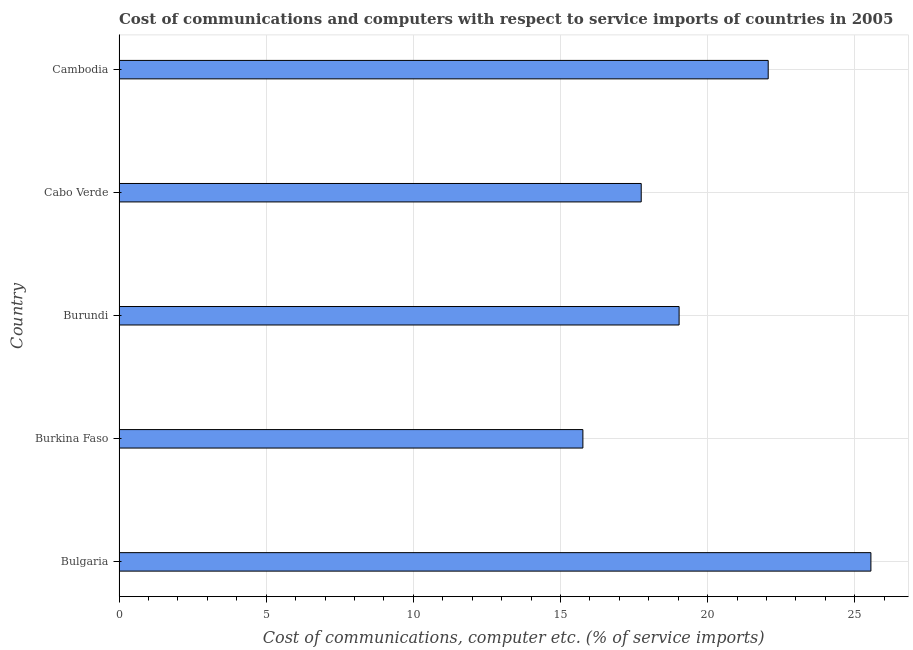Does the graph contain any zero values?
Provide a short and direct response. No. Does the graph contain grids?
Keep it short and to the point. Yes. What is the title of the graph?
Keep it short and to the point. Cost of communications and computers with respect to service imports of countries in 2005. What is the label or title of the X-axis?
Give a very brief answer. Cost of communications, computer etc. (% of service imports). What is the label or title of the Y-axis?
Make the answer very short. Country. What is the cost of communications and computer in Cabo Verde?
Your response must be concise. 17.74. Across all countries, what is the maximum cost of communications and computer?
Give a very brief answer. 25.55. Across all countries, what is the minimum cost of communications and computer?
Your answer should be compact. 15.76. In which country was the cost of communications and computer minimum?
Make the answer very short. Burkina Faso. What is the sum of the cost of communications and computer?
Keep it short and to the point. 100.13. What is the difference between the cost of communications and computer in Bulgaria and Burundi?
Make the answer very short. 6.52. What is the average cost of communications and computer per country?
Provide a short and direct response. 20.03. What is the median cost of communications and computer?
Provide a succinct answer. 19.03. In how many countries, is the cost of communications and computer greater than 15 %?
Your response must be concise. 5. What is the ratio of the cost of communications and computer in Bulgaria to that in Burkina Faso?
Give a very brief answer. 1.62. What is the difference between the highest and the second highest cost of communications and computer?
Offer a terse response. 3.49. Is the sum of the cost of communications and computer in Bulgaria and Cambodia greater than the maximum cost of communications and computer across all countries?
Offer a very short reply. Yes. What is the difference between the highest and the lowest cost of communications and computer?
Ensure brevity in your answer.  9.79. In how many countries, is the cost of communications and computer greater than the average cost of communications and computer taken over all countries?
Ensure brevity in your answer.  2. How many countries are there in the graph?
Provide a short and direct response. 5. What is the difference between two consecutive major ticks on the X-axis?
Make the answer very short. 5. Are the values on the major ticks of X-axis written in scientific E-notation?
Your response must be concise. No. What is the Cost of communications, computer etc. (% of service imports) in Bulgaria?
Provide a succinct answer. 25.55. What is the Cost of communications, computer etc. (% of service imports) of Burkina Faso?
Make the answer very short. 15.76. What is the Cost of communications, computer etc. (% of service imports) in Burundi?
Your answer should be compact. 19.03. What is the Cost of communications, computer etc. (% of service imports) of Cabo Verde?
Keep it short and to the point. 17.74. What is the Cost of communications, computer etc. (% of service imports) in Cambodia?
Keep it short and to the point. 22.06. What is the difference between the Cost of communications, computer etc. (% of service imports) in Bulgaria and Burkina Faso?
Ensure brevity in your answer.  9.79. What is the difference between the Cost of communications, computer etc. (% of service imports) in Bulgaria and Burundi?
Provide a short and direct response. 6.52. What is the difference between the Cost of communications, computer etc. (% of service imports) in Bulgaria and Cabo Verde?
Give a very brief answer. 7.8. What is the difference between the Cost of communications, computer etc. (% of service imports) in Bulgaria and Cambodia?
Your response must be concise. 3.49. What is the difference between the Cost of communications, computer etc. (% of service imports) in Burkina Faso and Burundi?
Your answer should be compact. -3.27. What is the difference between the Cost of communications, computer etc. (% of service imports) in Burkina Faso and Cabo Verde?
Provide a succinct answer. -1.98. What is the difference between the Cost of communications, computer etc. (% of service imports) in Burkina Faso and Cambodia?
Make the answer very short. -6.3. What is the difference between the Cost of communications, computer etc. (% of service imports) in Burundi and Cabo Verde?
Offer a terse response. 1.29. What is the difference between the Cost of communications, computer etc. (% of service imports) in Burundi and Cambodia?
Your answer should be compact. -3.03. What is the difference between the Cost of communications, computer etc. (% of service imports) in Cabo Verde and Cambodia?
Your answer should be very brief. -4.31. What is the ratio of the Cost of communications, computer etc. (% of service imports) in Bulgaria to that in Burkina Faso?
Make the answer very short. 1.62. What is the ratio of the Cost of communications, computer etc. (% of service imports) in Bulgaria to that in Burundi?
Your response must be concise. 1.34. What is the ratio of the Cost of communications, computer etc. (% of service imports) in Bulgaria to that in Cabo Verde?
Keep it short and to the point. 1.44. What is the ratio of the Cost of communications, computer etc. (% of service imports) in Bulgaria to that in Cambodia?
Give a very brief answer. 1.16. What is the ratio of the Cost of communications, computer etc. (% of service imports) in Burkina Faso to that in Burundi?
Ensure brevity in your answer.  0.83. What is the ratio of the Cost of communications, computer etc. (% of service imports) in Burkina Faso to that in Cabo Verde?
Provide a short and direct response. 0.89. What is the ratio of the Cost of communications, computer etc. (% of service imports) in Burkina Faso to that in Cambodia?
Ensure brevity in your answer.  0.71. What is the ratio of the Cost of communications, computer etc. (% of service imports) in Burundi to that in Cabo Verde?
Your answer should be very brief. 1.07. What is the ratio of the Cost of communications, computer etc. (% of service imports) in Burundi to that in Cambodia?
Ensure brevity in your answer.  0.86. What is the ratio of the Cost of communications, computer etc. (% of service imports) in Cabo Verde to that in Cambodia?
Your answer should be compact. 0.8. 